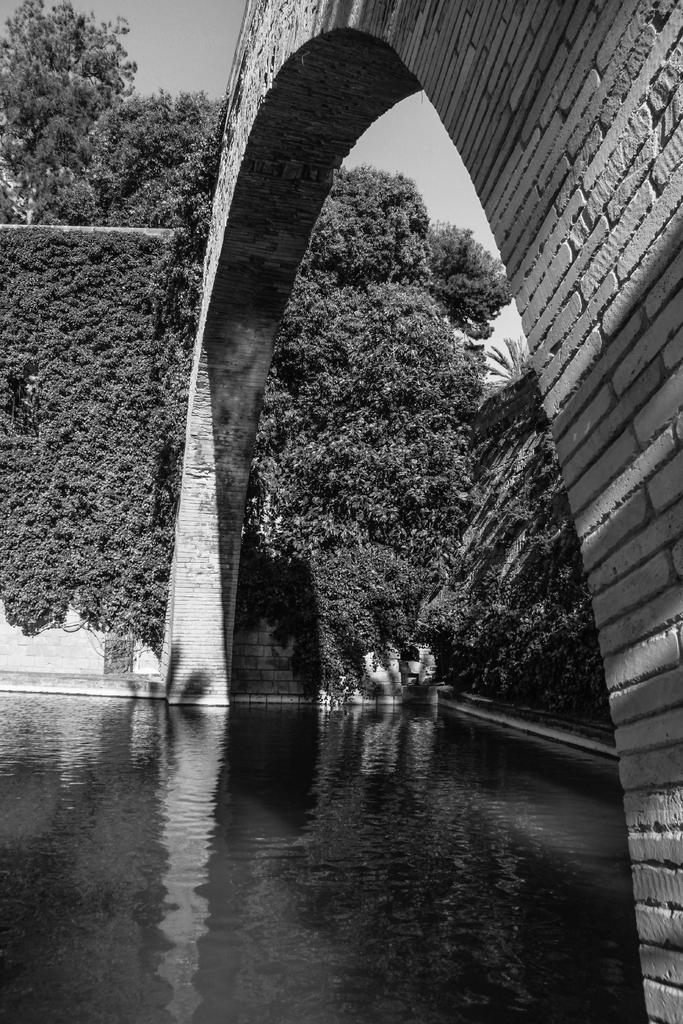What type of structure can be seen in the image? There is an arch in the image. What is visible at the bottom of the image? There is water visible at the bottom of the image. What can be seen in the background of the image? There is a brick wall, plants, trees, and the sky visible in the background of the image. What type of fruit is hanging from the arch in the image? There is no fruit, including quince, hanging from the arch in the image. What type of crook is present in the image? There is no crook present in the image. 